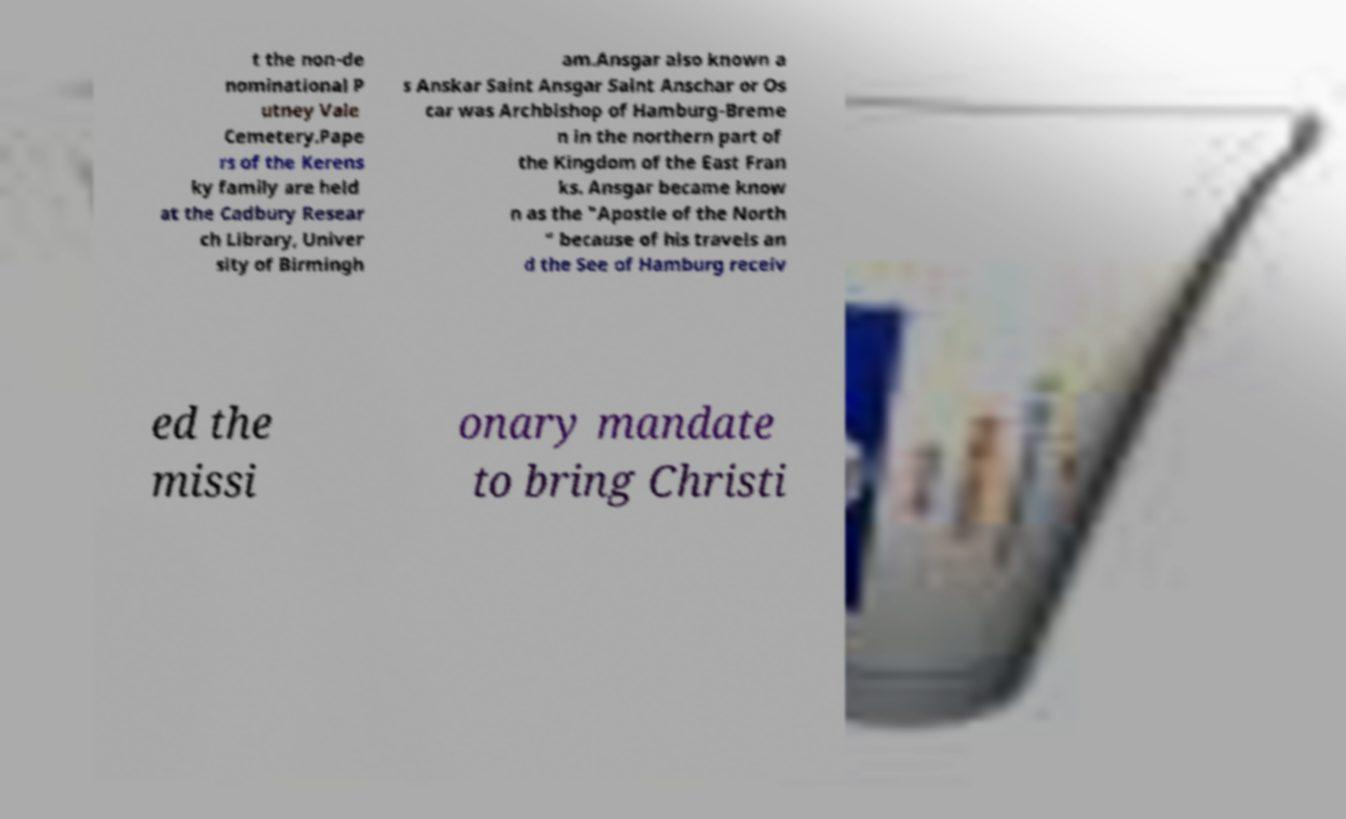What messages or text are displayed in this image? I need them in a readable, typed format. t the non-de nominational P utney Vale Cemetery.Pape rs of the Kerens ky family are held at the Cadbury Resear ch Library, Univer sity of Birmingh am.Ansgar also known a s Anskar Saint Ansgar Saint Anschar or Os car was Archbishop of Hamburg-Breme n in the northern part of the Kingdom of the East Fran ks. Ansgar became know n as the "Apostle of the North " because of his travels an d the See of Hamburg receiv ed the missi onary mandate to bring Christi 